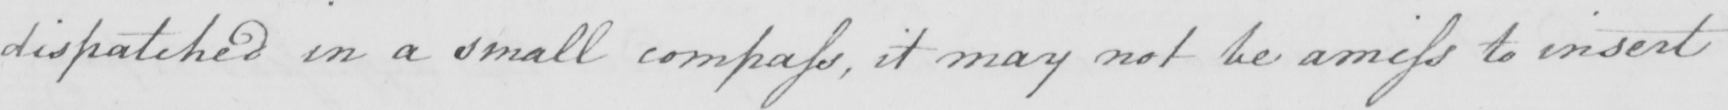Can you read and transcribe this handwriting? dispatched in a small compass , it may not be amiss to insert 